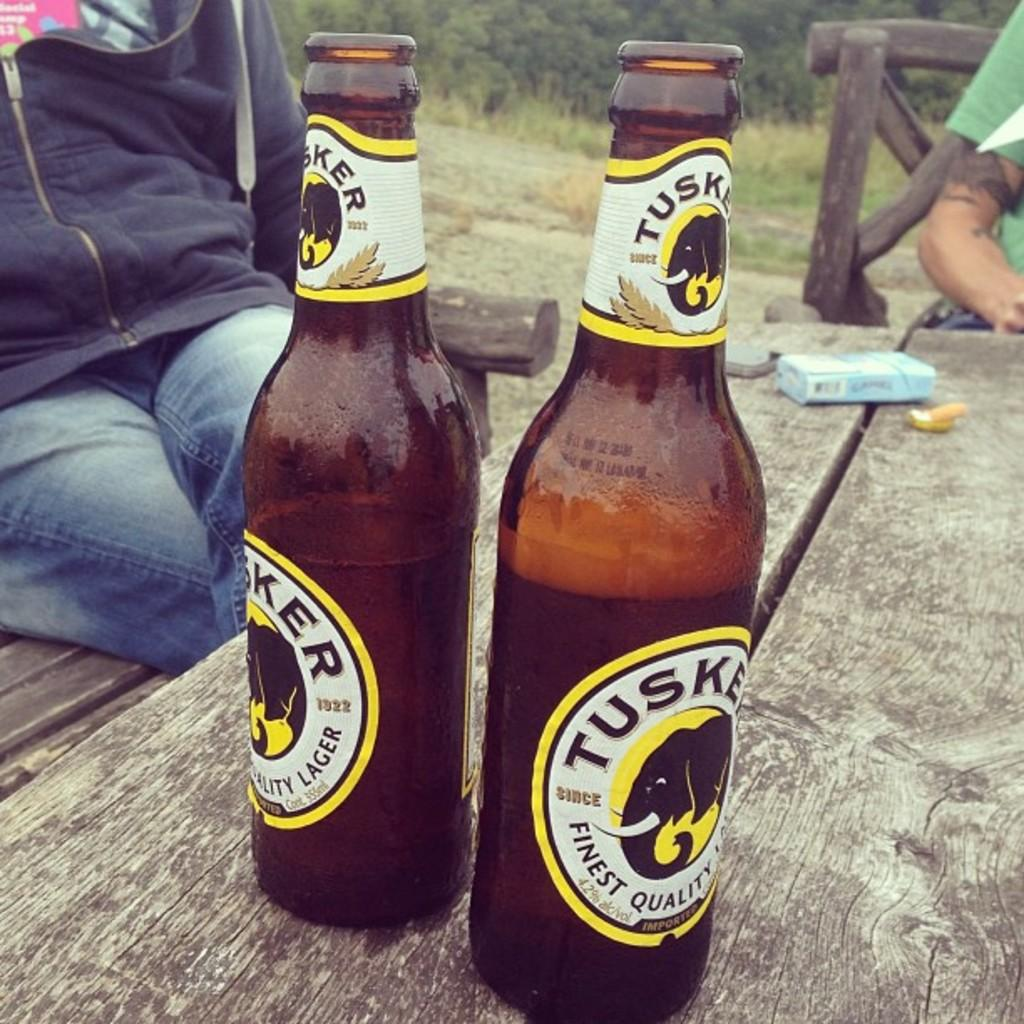What type of furniture is present in the image? There is a table and chairs in the image. How many people are sitting in the chairs? Two persons are sitting in the chairs. What can be seen on the table? There are two bottles and a box on the table. What type of clouds can be seen in the image? There are no clouds visible in the image, as it is focused on the table, chairs, and people. 